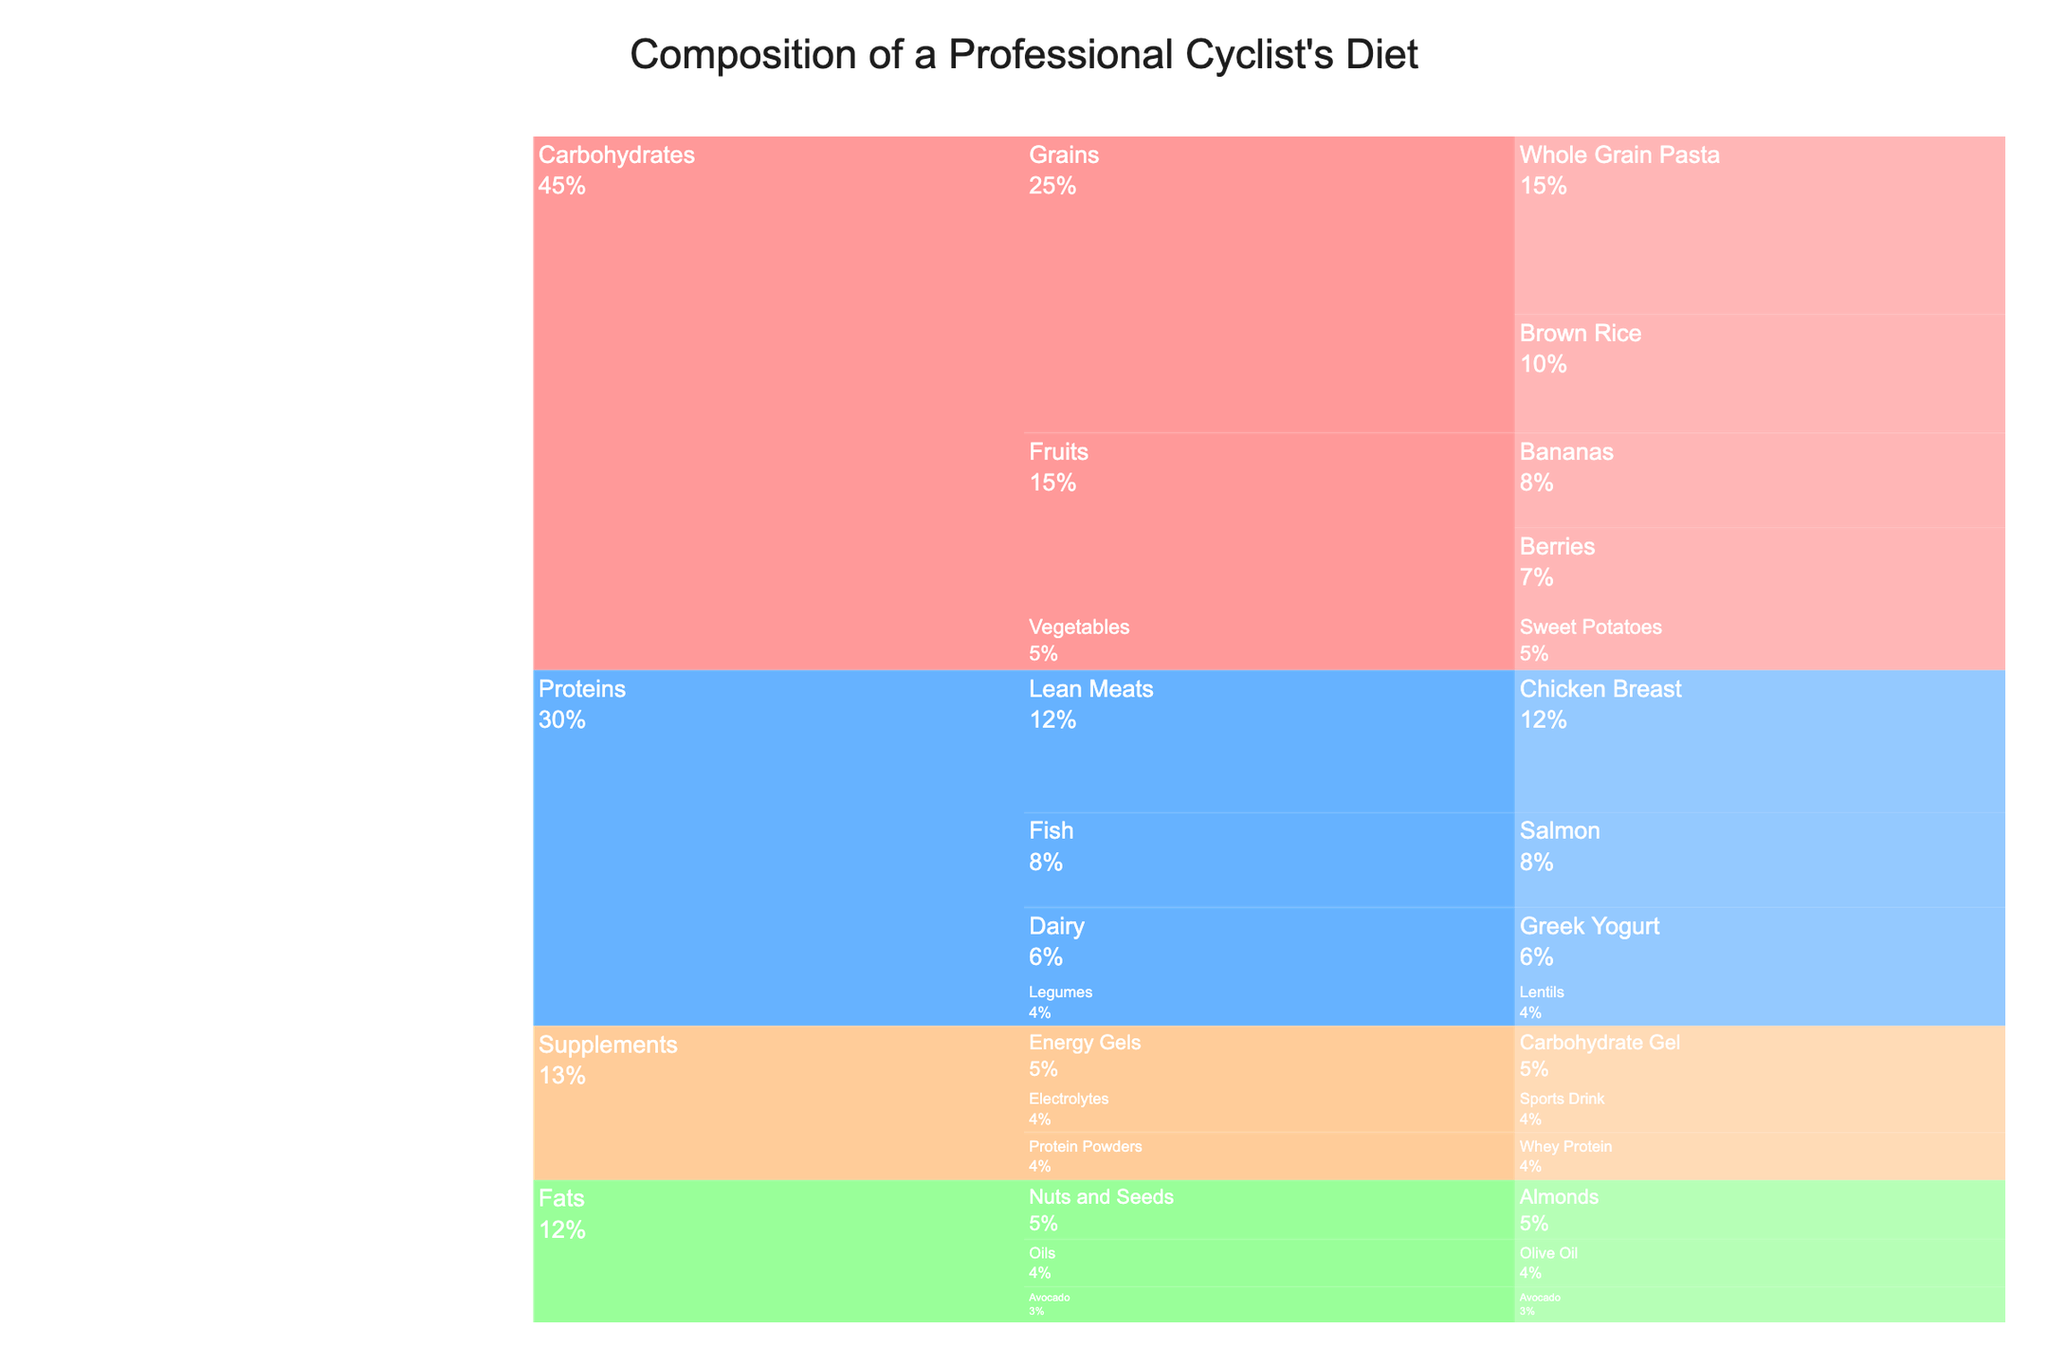What is the largest single food item by percentage in the professional cyclist's diet? By looking at the chart, the largest segment represents Whole Grain Pasta with a percentage of 15%.
Answer: Whole Grain Pasta What macronutrient category has the highest total percentage in the diet? By evaluating the sum of percentages within each macronutrient category, Carbohydrates have the highest total percentage (15 + 10 + 8 + 7 + 5 = 45%).
Answer: Carbohydrates How does the total percentage of Supplements compare to that of Fats? The total percentage for Supplements is (5 + 4 + 4 = 13%) and for Fats is (5 + 4 + 3 = 12%). Supplements have a slightly higher percentage than Fats.
Answer: Supplements > Fats Which food group within Carbohydrates contributes the least to the diet? Within Carbohydrates, the food groups and their total contributions are Grains (15 + 10 = 25%), Fruits (8 + 7 = 15%), and Vegetables (5%). Therefore, Vegetables contribute the least.
Answer: Vegetables What is the combined percentage of Grains from both Carbohydrates and Fats categories? The Grains within Carbohydrates have 15% from Whole Grain Pasta and 10% from Brown Rice, combining to 25%. Fats do not have a Grains group, so the combined percentage remains 25%.
Answer: 25% Which has a higher percentage: Chicken Breast or Salmon? Looking at the chart, Chicken Breast has 12%, and Salmon has 8%. Thus, Chicken Breast has a higher percentage.
Answer: Chicken Breast What is the percentage difference between Fruits and Dairy in the diet? The total percentage for Fruits is 15% (8% Bananas + 7% Berries) and for Dairy is 6% from Greek Yogurt. The difference is 15% - 6% = 9%.
Answer: 9% Which food item has the lowest percentage, and what is its value? Observing the chart, Avocado has the lowest percentage at 3%.
Answer: Avocado, 3% What is the percentage contribution of Lean Meats within the Proteins category? The only item under Lean Meats in the Proteins category is Chicken Breast at 12%.
Answer: 12% What is the total combined percentage of all the items in the Vegetables and Energy Gels groups? The Vegetables group has 5% from Sweet Potatoes, and the Energy Gels group also has 5% from Carbohydrate Gel. The combined percentage is 5% + 5% = 10%.
Answer: 10% 